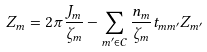Convert formula to latex. <formula><loc_0><loc_0><loc_500><loc_500>Z _ { m } = 2 \pi \frac { J _ { m } } { \zeta _ { m } } - \sum _ { m ^ { \prime } \in \mathcal { C } } \frac { n _ { m } } { \zeta _ { m } } t _ { m m ^ { \prime } } Z _ { m ^ { \prime } }</formula> 